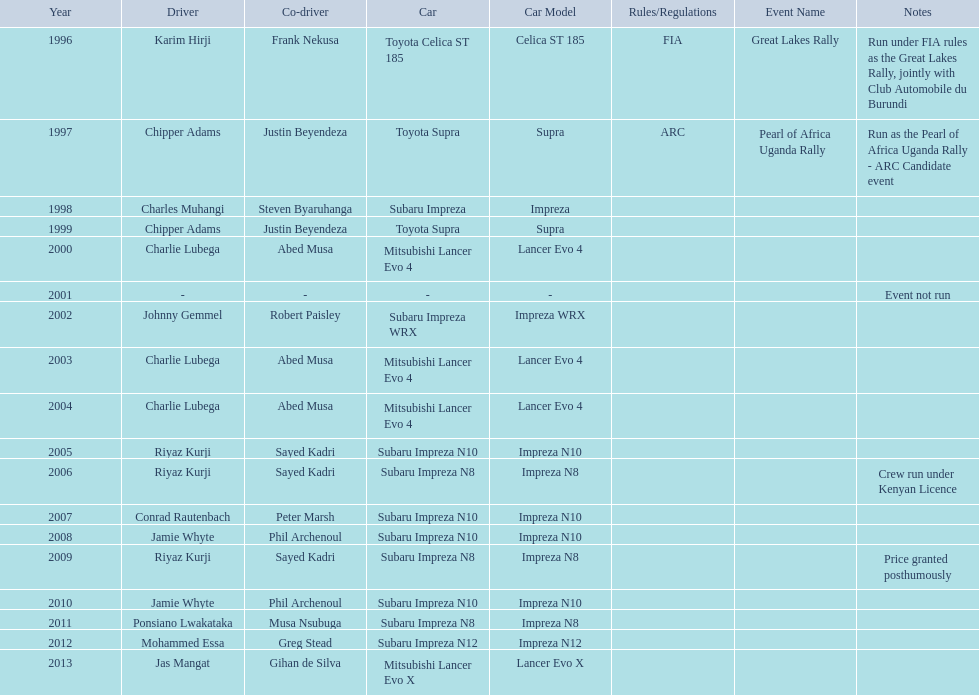How many drivers won at least twice? 4. 